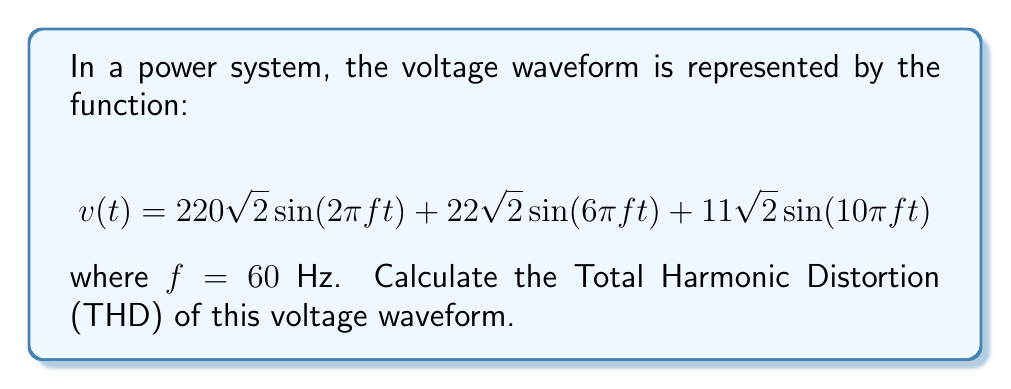Give your solution to this math problem. Let's approach this step-by-step:

1) The Total Harmonic Distortion (THD) is defined as:

   $$THD = \frac{\sqrt{\sum_{n=2}^{\infty} V_n^2}}{V_1}$$

   where $V_1$ is the RMS value of the fundamental component and $V_n$ are the RMS values of the harmonic components.

2) From the given waveform, we can identify:
   - Fundamental (1st harmonic): $220\sqrt{2}\sin(2\pi f t)$
   - 3rd harmonic: $22\sqrt{2}\sin(6\pi f t)$
   - 5th harmonic: $11\sqrt{2}\sin(10\pi f t)$

3) Calculate the RMS values:
   - $V_1 = 220$ V (RMS)
   - $V_3 = 22$ V (RMS)
   - $V_5 = 11$ V (RMS)

4) Apply the THD formula:

   $$THD = \frac{\sqrt{V_3^2 + V_5^2}}{V_1}$$

5) Substitute the values:

   $$THD = \frac{\sqrt{22^2 + 11^2}}{220}$$

6) Calculate:

   $$THD = \frac{\sqrt{484 + 121}}{220} = \frac{\sqrt{605}}{220} \approx 0.1118$$

7) Convert to percentage:

   $$THD \approx 0.1118 \times 100\% = 11.18\%$$
Answer: 11.18% 